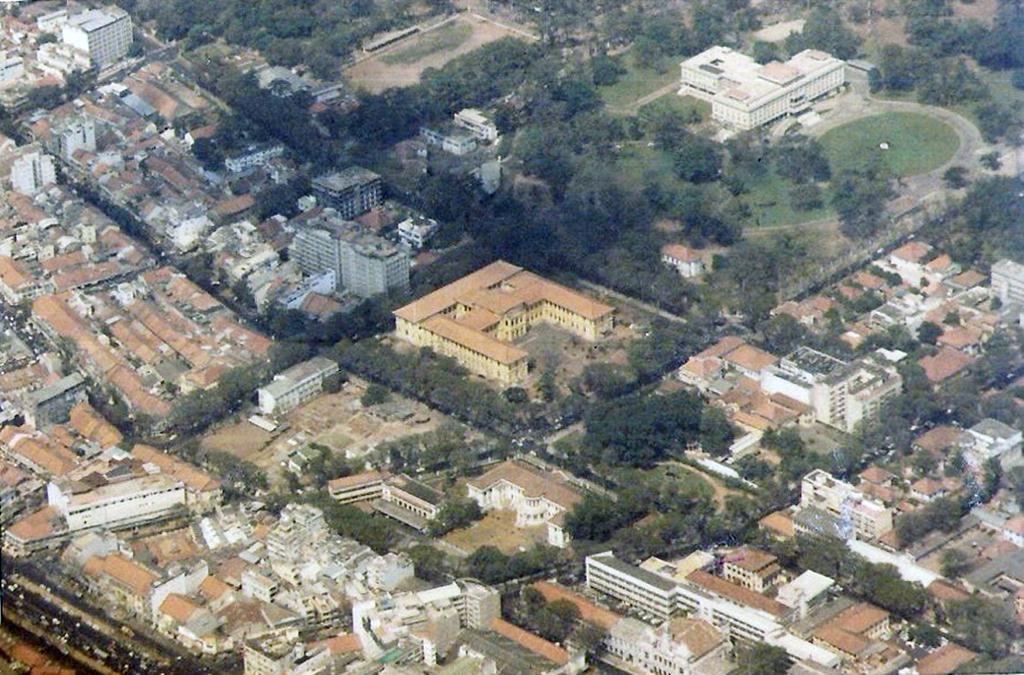What perspective is the image taken from? The image shows a top view of a city. What types of structures can be seen in the image? There are many buildings and houses in the image. Are there any natural elements visible in the image? Yes, trees are present in the image. How many centimeters of pollution can be seen above the city in the image? There is no visible pollution in the image, and therefore no measurement can be provided. What type of bean is growing on the roof of the building in the image? There are no beans present in the image, and no plants are visible on the roof of any building. 